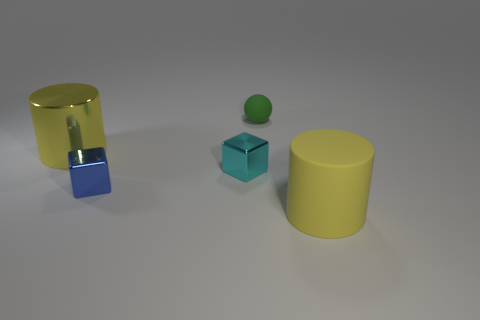Subtract all cyan blocks. How many blocks are left? 1 Subtract all cylinders. How many objects are left? 3 Add 1 small cyan metal objects. How many objects exist? 6 Subtract all brown cylinders. How many gray balls are left? 0 Add 2 yellow cylinders. How many yellow cylinders are left? 4 Add 3 blue cylinders. How many blue cylinders exist? 3 Subtract 1 cyan blocks. How many objects are left? 4 Subtract 1 cylinders. How many cylinders are left? 1 Subtract all blue cubes. Subtract all purple spheres. How many cubes are left? 1 Subtract all small things. Subtract all blue shiny cubes. How many objects are left? 1 